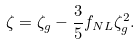<formula> <loc_0><loc_0><loc_500><loc_500>\zeta = \zeta _ { g } - \frac { 3 } { 5 } f _ { N L } \zeta _ { g } ^ { 2 } .</formula> 